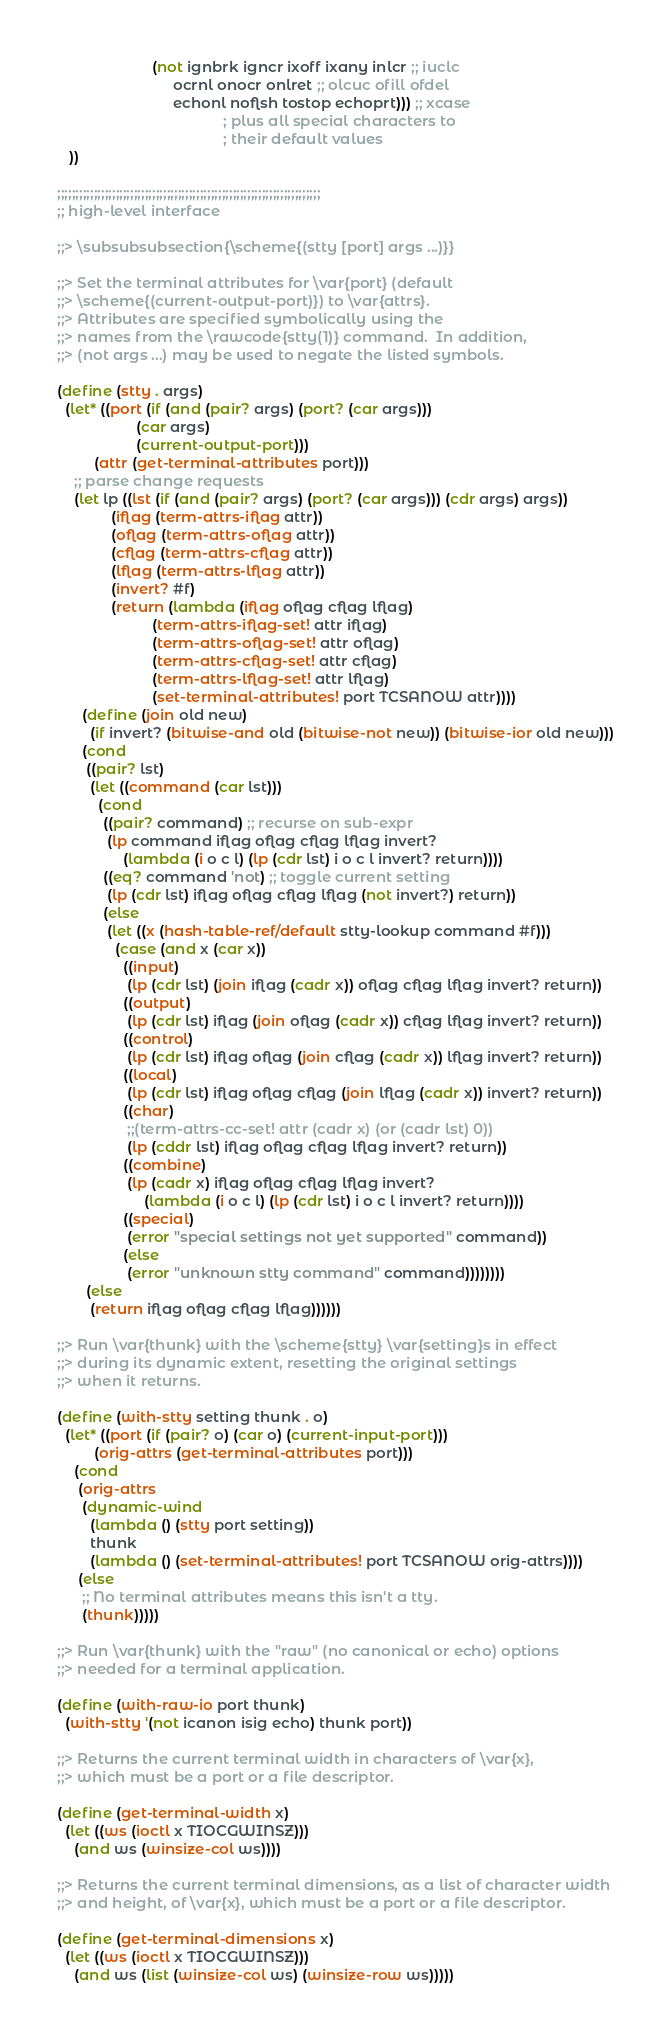Convert code to text. <code><loc_0><loc_0><loc_500><loc_500><_Scheme_>                       (not ignbrk igncr ixoff ixany inlcr ;; iuclc
                            ocrnl onocr onlret ;; olcuc ofill ofdel
                            echonl noflsh tostop echoprt))) ;; xcase
                                        ; plus all special characters to
                                        ; their default values
   ))

;;;;;;;;;;;;;;;;;;;;;;;;;;;;;;;;;;;;;;;;;;;;;;;;;;;;;;;;;;;;;;;;;;;;;;;;
;; high-level interface

;;> \subsubsubsection{\scheme{(stty [port] args ...)}}

;;> Set the terminal attributes for \var{port} (default
;;> \scheme{(current-output-port)}) to \var{attrs}.
;;> Attributes are specified symbolically using the
;;> names from the \rawcode{stty(1)} command.  In addition,
;;> (not args ...) may be used to negate the listed symbols.

(define (stty . args)
  (let* ((port (if (and (pair? args) (port? (car args)))
                   (car args)
                   (current-output-port)))
         (attr (get-terminal-attributes port)))
    ;; parse change requests
    (let lp ((lst (if (and (pair? args) (port? (car args))) (cdr args) args))
             (iflag (term-attrs-iflag attr))
             (oflag (term-attrs-oflag attr))
             (cflag (term-attrs-cflag attr))
             (lflag (term-attrs-lflag attr))
             (invert? #f)
             (return (lambda (iflag oflag cflag lflag)
                       (term-attrs-iflag-set! attr iflag)
                       (term-attrs-oflag-set! attr oflag)
                       (term-attrs-cflag-set! attr cflag)
                       (term-attrs-lflag-set! attr lflag)
                       (set-terminal-attributes! port TCSANOW attr))))
      (define (join old new)
        (if invert? (bitwise-and old (bitwise-not new)) (bitwise-ior old new)))
      (cond
       ((pair? lst)
        (let ((command (car lst)))
          (cond
           ((pair? command) ;; recurse on sub-expr
            (lp command iflag oflag cflag lflag invert?
                (lambda (i o c l) (lp (cdr lst) i o c l invert? return))))
           ((eq? command 'not) ;; toggle current setting
            (lp (cdr lst) iflag oflag cflag lflag (not invert?) return))
           (else
            (let ((x (hash-table-ref/default stty-lookup command #f)))
              (case (and x (car x))
                ((input)
                 (lp (cdr lst) (join iflag (cadr x)) oflag cflag lflag invert? return))
                ((output)
                 (lp (cdr lst) iflag (join oflag (cadr x)) cflag lflag invert? return))
                ((control)
                 (lp (cdr lst) iflag oflag (join cflag (cadr x)) lflag invert? return))
                ((local)
                 (lp (cdr lst) iflag oflag cflag (join lflag (cadr x)) invert? return))
                ((char)
                 ;;(term-attrs-cc-set! attr (cadr x) (or (cadr lst) 0))
                 (lp (cddr lst) iflag oflag cflag lflag invert? return))
                ((combine)
                 (lp (cadr x) iflag oflag cflag lflag invert?
                     (lambda (i o c l) (lp (cdr lst) i o c l invert? return))))
                ((special)
                 (error "special settings not yet supported" command))
                (else
                 (error "unknown stty command" command))))))))
       (else
        (return iflag oflag cflag lflag))))))

;;> Run \var{thunk} with the \scheme{stty} \var{setting}s in effect
;;> during its dynamic extent, resetting the original settings
;;> when it returns.

(define (with-stty setting thunk . o)
  (let* ((port (if (pair? o) (car o) (current-input-port)))
         (orig-attrs (get-terminal-attributes port)))
    (cond
     (orig-attrs
      (dynamic-wind
        (lambda () (stty port setting))
        thunk
        (lambda () (set-terminal-attributes! port TCSANOW orig-attrs))))
     (else
      ;; No terminal attributes means this isn't a tty.
      (thunk)))))

;;> Run \var{thunk} with the "raw" (no canonical or echo) options
;;> needed for a terminal application.

(define (with-raw-io port thunk)
  (with-stty '(not icanon isig echo) thunk port))

;;> Returns the current terminal width in characters of \var{x},
;;> which must be a port or a file descriptor.

(define (get-terminal-width x)
  (let ((ws (ioctl x TIOCGWINSZ)))
    (and ws (winsize-col ws))))

;;> Returns the current terminal dimensions, as a list of character width
;;> and height, of \var{x}, which must be a port or a file descriptor.

(define (get-terminal-dimensions x)
  (let ((ws (ioctl x TIOCGWINSZ)))
    (and ws (list (winsize-col ws) (winsize-row ws)))))
</code> 